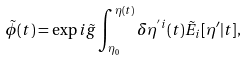Convert formula to latex. <formula><loc_0><loc_0><loc_500><loc_500>\tilde { \phi } ( t ) = \exp i \tilde { g } \int _ { \eta _ { 0 } } ^ { \eta ( t ) } \delta \eta ^ { ^ { \prime } i } ( t ) \tilde { E } _ { i } [ \eta ^ { \prime } | t ] ,</formula> 